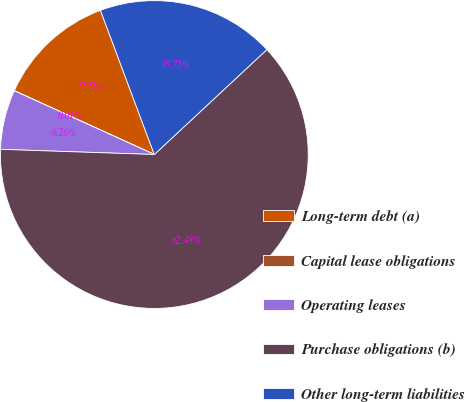<chart> <loc_0><loc_0><loc_500><loc_500><pie_chart><fcel>Long-term debt (a)<fcel>Capital lease obligations<fcel>Operating leases<fcel>Purchase obligations (b)<fcel>Other long-term liabilities<nl><fcel>12.5%<fcel>0.01%<fcel>6.26%<fcel>62.48%<fcel>18.75%<nl></chart> 